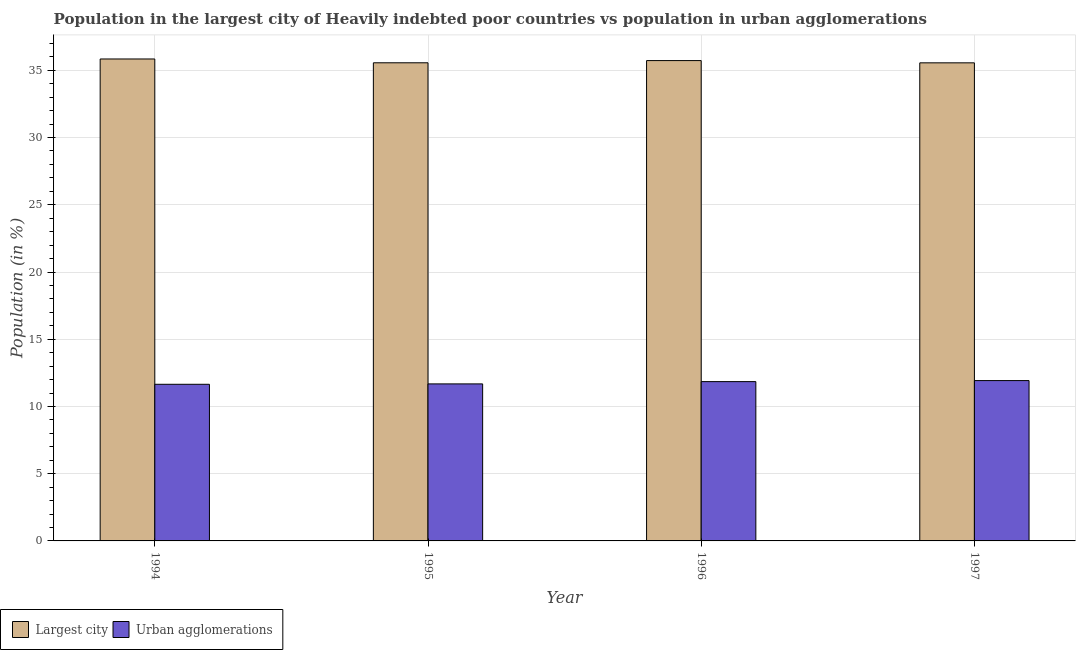How many different coloured bars are there?
Your answer should be very brief. 2. How many groups of bars are there?
Ensure brevity in your answer.  4. Are the number of bars on each tick of the X-axis equal?
Offer a terse response. Yes. What is the label of the 1st group of bars from the left?
Keep it short and to the point. 1994. What is the population in urban agglomerations in 1995?
Your answer should be compact. 11.68. Across all years, what is the maximum population in the largest city?
Offer a terse response. 35.84. Across all years, what is the minimum population in the largest city?
Offer a terse response. 35.56. In which year was the population in urban agglomerations maximum?
Your answer should be very brief. 1997. What is the total population in urban agglomerations in the graph?
Give a very brief answer. 47.1. What is the difference between the population in urban agglomerations in 1994 and that in 1995?
Your answer should be compact. -0.03. What is the difference between the population in urban agglomerations in 1997 and the population in the largest city in 1994?
Provide a short and direct response. 0.28. What is the average population in urban agglomerations per year?
Offer a very short reply. 11.78. In the year 1994, what is the difference between the population in the largest city and population in urban agglomerations?
Your response must be concise. 0. What is the ratio of the population in urban agglomerations in 1995 to that in 1997?
Your response must be concise. 0.98. Is the population in urban agglomerations in 1996 less than that in 1997?
Make the answer very short. Yes. Is the difference between the population in urban agglomerations in 1994 and 1996 greater than the difference between the population in the largest city in 1994 and 1996?
Keep it short and to the point. No. What is the difference between the highest and the second highest population in urban agglomerations?
Your answer should be compact. 0.08. What is the difference between the highest and the lowest population in urban agglomerations?
Offer a very short reply. 0.28. In how many years, is the population in urban agglomerations greater than the average population in urban agglomerations taken over all years?
Provide a short and direct response. 2. Is the sum of the population in the largest city in 1995 and 1996 greater than the maximum population in urban agglomerations across all years?
Ensure brevity in your answer.  Yes. What does the 1st bar from the left in 1995 represents?
Give a very brief answer. Largest city. What does the 1st bar from the right in 1995 represents?
Offer a terse response. Urban agglomerations. How many bars are there?
Provide a short and direct response. 8. Where does the legend appear in the graph?
Give a very brief answer. Bottom left. How many legend labels are there?
Ensure brevity in your answer.  2. How are the legend labels stacked?
Offer a terse response. Horizontal. What is the title of the graph?
Keep it short and to the point. Population in the largest city of Heavily indebted poor countries vs population in urban agglomerations. Does "Formally registered" appear as one of the legend labels in the graph?
Provide a succinct answer. No. What is the label or title of the X-axis?
Offer a very short reply. Year. What is the label or title of the Y-axis?
Your answer should be very brief. Population (in %). What is the Population (in %) in Largest city in 1994?
Provide a short and direct response. 35.84. What is the Population (in %) in Urban agglomerations in 1994?
Provide a short and direct response. 11.65. What is the Population (in %) of Largest city in 1995?
Offer a terse response. 35.56. What is the Population (in %) in Urban agglomerations in 1995?
Offer a very short reply. 11.68. What is the Population (in %) of Largest city in 1996?
Offer a terse response. 35.72. What is the Population (in %) in Urban agglomerations in 1996?
Your response must be concise. 11.85. What is the Population (in %) of Largest city in 1997?
Make the answer very short. 35.56. What is the Population (in %) of Urban agglomerations in 1997?
Offer a terse response. 11.92. Across all years, what is the maximum Population (in %) in Largest city?
Your answer should be very brief. 35.84. Across all years, what is the maximum Population (in %) of Urban agglomerations?
Ensure brevity in your answer.  11.92. Across all years, what is the minimum Population (in %) in Largest city?
Give a very brief answer. 35.56. Across all years, what is the minimum Population (in %) of Urban agglomerations?
Ensure brevity in your answer.  11.65. What is the total Population (in %) in Largest city in the graph?
Provide a succinct answer. 142.68. What is the total Population (in %) of Urban agglomerations in the graph?
Ensure brevity in your answer.  47.1. What is the difference between the Population (in %) of Largest city in 1994 and that in 1995?
Ensure brevity in your answer.  0.28. What is the difference between the Population (in %) of Urban agglomerations in 1994 and that in 1995?
Your response must be concise. -0.03. What is the difference between the Population (in %) of Largest city in 1994 and that in 1996?
Offer a terse response. 0.12. What is the difference between the Population (in %) of Urban agglomerations in 1994 and that in 1996?
Your response must be concise. -0.2. What is the difference between the Population (in %) in Largest city in 1994 and that in 1997?
Provide a short and direct response. 0.29. What is the difference between the Population (in %) of Urban agglomerations in 1994 and that in 1997?
Give a very brief answer. -0.28. What is the difference between the Population (in %) of Largest city in 1995 and that in 1996?
Make the answer very short. -0.16. What is the difference between the Population (in %) of Urban agglomerations in 1995 and that in 1996?
Provide a short and direct response. -0.17. What is the difference between the Population (in %) in Largest city in 1995 and that in 1997?
Offer a very short reply. 0. What is the difference between the Population (in %) in Urban agglomerations in 1995 and that in 1997?
Ensure brevity in your answer.  -0.25. What is the difference between the Population (in %) of Largest city in 1996 and that in 1997?
Give a very brief answer. 0.17. What is the difference between the Population (in %) in Urban agglomerations in 1996 and that in 1997?
Offer a very short reply. -0.08. What is the difference between the Population (in %) of Largest city in 1994 and the Population (in %) of Urban agglomerations in 1995?
Give a very brief answer. 24.17. What is the difference between the Population (in %) of Largest city in 1994 and the Population (in %) of Urban agglomerations in 1996?
Give a very brief answer. 24. What is the difference between the Population (in %) of Largest city in 1994 and the Population (in %) of Urban agglomerations in 1997?
Offer a very short reply. 23.92. What is the difference between the Population (in %) of Largest city in 1995 and the Population (in %) of Urban agglomerations in 1996?
Give a very brief answer. 23.71. What is the difference between the Population (in %) in Largest city in 1995 and the Population (in %) in Urban agglomerations in 1997?
Offer a terse response. 23.64. What is the difference between the Population (in %) in Largest city in 1996 and the Population (in %) in Urban agglomerations in 1997?
Offer a very short reply. 23.8. What is the average Population (in %) of Largest city per year?
Your answer should be compact. 35.67. What is the average Population (in %) in Urban agglomerations per year?
Your answer should be very brief. 11.78. In the year 1994, what is the difference between the Population (in %) in Largest city and Population (in %) in Urban agglomerations?
Your answer should be compact. 24.19. In the year 1995, what is the difference between the Population (in %) of Largest city and Population (in %) of Urban agglomerations?
Your response must be concise. 23.88. In the year 1996, what is the difference between the Population (in %) of Largest city and Population (in %) of Urban agglomerations?
Make the answer very short. 23.88. In the year 1997, what is the difference between the Population (in %) in Largest city and Population (in %) in Urban agglomerations?
Offer a terse response. 23.63. What is the ratio of the Population (in %) of Urban agglomerations in 1994 to that in 1995?
Your response must be concise. 1. What is the ratio of the Population (in %) in Urban agglomerations in 1994 to that in 1996?
Make the answer very short. 0.98. What is the ratio of the Population (in %) of Largest city in 1994 to that in 1997?
Your response must be concise. 1.01. What is the ratio of the Population (in %) of Urban agglomerations in 1994 to that in 1997?
Offer a very short reply. 0.98. What is the ratio of the Population (in %) in Largest city in 1995 to that in 1996?
Ensure brevity in your answer.  1. What is the ratio of the Population (in %) in Urban agglomerations in 1995 to that in 1996?
Offer a very short reply. 0.99. What is the ratio of the Population (in %) in Largest city in 1995 to that in 1997?
Give a very brief answer. 1. What is the ratio of the Population (in %) of Urban agglomerations in 1995 to that in 1997?
Keep it short and to the point. 0.98. What is the ratio of the Population (in %) of Largest city in 1996 to that in 1997?
Make the answer very short. 1. What is the difference between the highest and the second highest Population (in %) in Largest city?
Give a very brief answer. 0.12. What is the difference between the highest and the second highest Population (in %) of Urban agglomerations?
Ensure brevity in your answer.  0.08. What is the difference between the highest and the lowest Population (in %) of Largest city?
Offer a terse response. 0.29. What is the difference between the highest and the lowest Population (in %) of Urban agglomerations?
Make the answer very short. 0.28. 